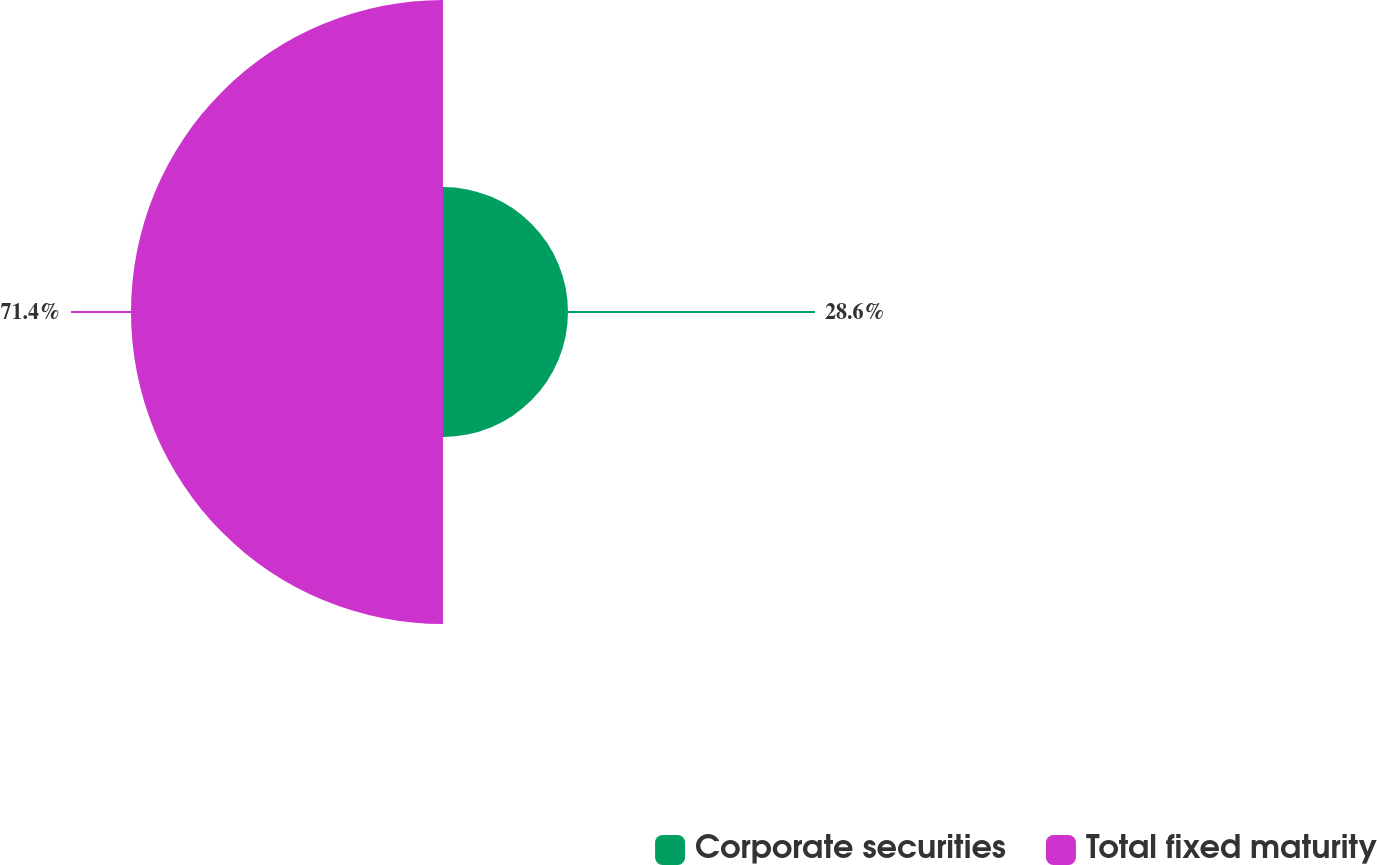Convert chart to OTSL. <chart><loc_0><loc_0><loc_500><loc_500><pie_chart><fcel>Corporate securities<fcel>Total fixed maturity<nl><fcel>28.6%<fcel>71.4%<nl></chart> 